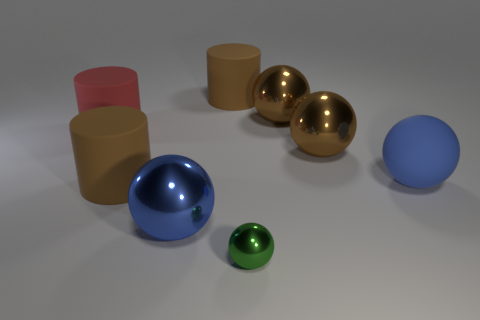The cylinder that is on the right side of the blue object in front of the brown matte cylinder that is in front of the red object is what color?
Offer a terse response. Brown. What number of other blue spheres have the same size as the rubber ball?
Your response must be concise. 1. The rubber thing that is behind the red cylinder is what color?
Your answer should be very brief. Brown. How many other objects are there of the same size as the green metallic ball?
Ensure brevity in your answer.  0. There is a metal sphere that is right of the big blue metal thing and in front of the rubber sphere; how big is it?
Offer a terse response. Small. There is a matte sphere; is its color the same as the ball that is left of the small green metallic thing?
Make the answer very short. Yes. Is there a brown object that has the same shape as the big red thing?
Keep it short and to the point. Yes. What number of objects are either blue objects or large brown things that are left of the tiny sphere?
Ensure brevity in your answer.  4. How many other things are there of the same material as the big red thing?
Provide a short and direct response. 3. What number of objects are either small green metallic objects or large matte cylinders?
Your response must be concise. 4. 